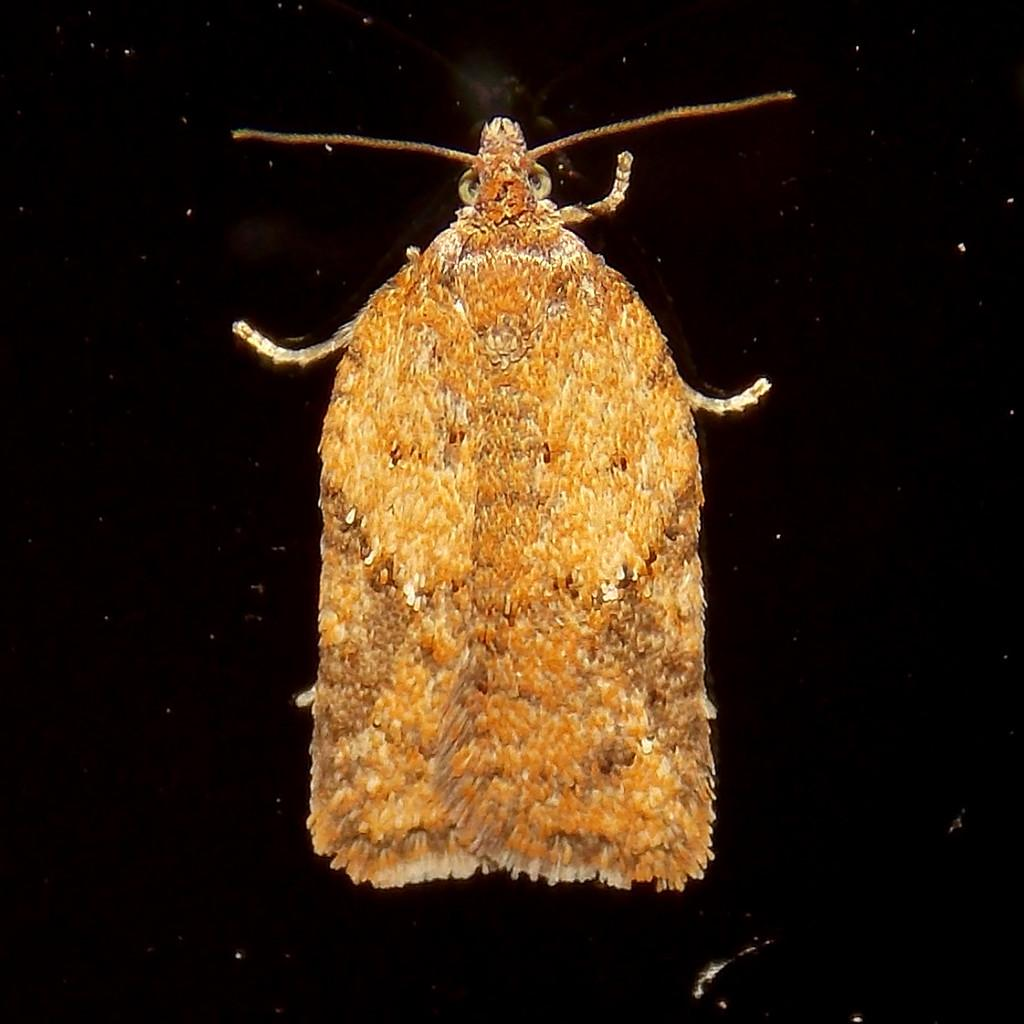What type of creature can be seen in the image? There is an insect in the image. What is the color of the surface on which the insect is located? The insect is on a black surface. Is the insect trying to deliver a parcel in the image? There is no parcel present in the image, and therefore no such activity can be observed. 